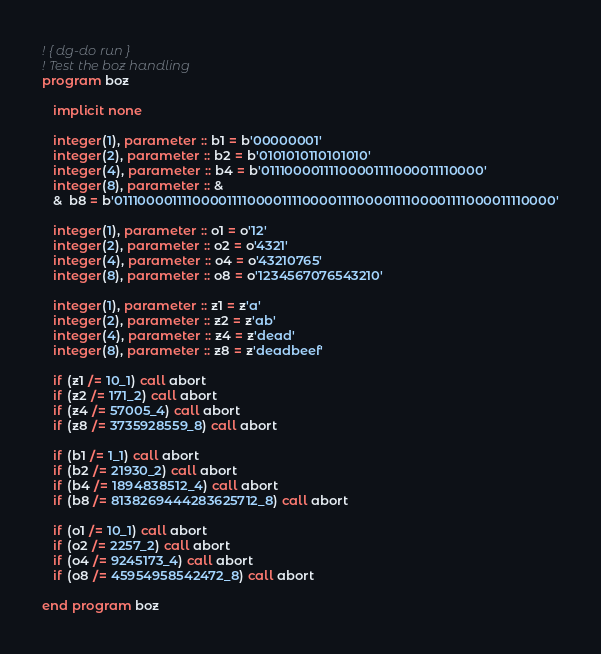Convert code to text. <code><loc_0><loc_0><loc_500><loc_500><_FORTRAN_>! { dg-do run }
! Test the boz handling
program boz

   implicit none

   integer(1), parameter :: b1 = b'00000001'
   integer(2), parameter :: b2 = b'0101010110101010'
   integer(4), parameter :: b4 = b'01110000111100001111000011110000'
   integer(8), parameter :: &
   &  b8 = b'0111000011110000111100001111000011110000111100001111000011110000'

   integer(1), parameter :: o1 = o'12'
   integer(2), parameter :: o2 = o'4321'
   integer(4), parameter :: o4 = o'43210765'
   integer(8), parameter :: o8 = o'1234567076543210'

   integer(1), parameter :: z1 = z'a'
   integer(2), parameter :: z2 = z'ab'
   integer(4), parameter :: z4 = z'dead'
   integer(8), parameter :: z8 = z'deadbeef'

   if (z1 /= 10_1) call abort
   if (z2 /= 171_2) call abort
   if (z4 /= 57005_4) call abort
   if (z8 /= 3735928559_8) call abort

   if (b1 /= 1_1) call abort
   if (b2 /= 21930_2) call abort
   if (b4 /= 1894838512_4) call abort
   if (b8 /= 8138269444283625712_8) call abort

   if (o1 /= 10_1) call abort
   if (o2 /= 2257_2) call abort
   if (o4 /= 9245173_4) call abort
   if (o8 /= 45954958542472_8) call abort

end program boz
</code> 